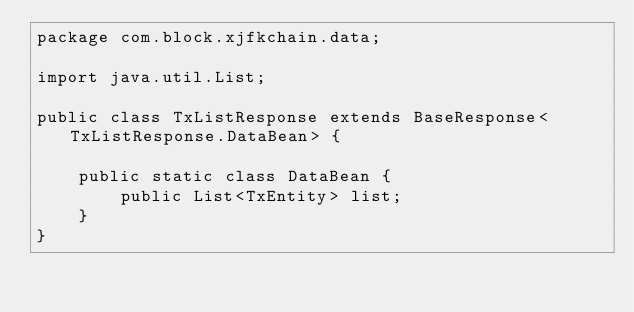<code> <loc_0><loc_0><loc_500><loc_500><_Java_>package com.block.xjfkchain.data;

import java.util.List;

public class TxListResponse extends BaseResponse<TxListResponse.DataBean> {

    public static class DataBean {
        public List<TxEntity> list;
    }
}
</code> 